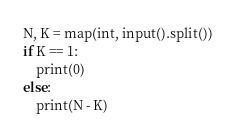Convert code to text. <code><loc_0><loc_0><loc_500><loc_500><_Python_>N, K = map(int, input().split())
if K == 1:
    print(0)
else:
    print(N - K)</code> 